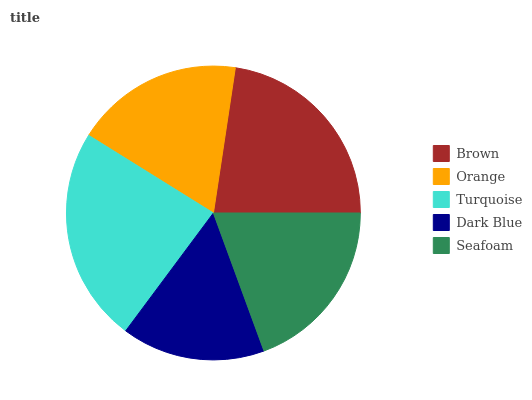Is Dark Blue the minimum?
Answer yes or no. Yes. Is Turquoise the maximum?
Answer yes or no. Yes. Is Orange the minimum?
Answer yes or no. No. Is Orange the maximum?
Answer yes or no. No. Is Brown greater than Orange?
Answer yes or no. Yes. Is Orange less than Brown?
Answer yes or no. Yes. Is Orange greater than Brown?
Answer yes or no. No. Is Brown less than Orange?
Answer yes or no. No. Is Seafoam the high median?
Answer yes or no. Yes. Is Seafoam the low median?
Answer yes or no. Yes. Is Dark Blue the high median?
Answer yes or no. No. Is Dark Blue the low median?
Answer yes or no. No. 